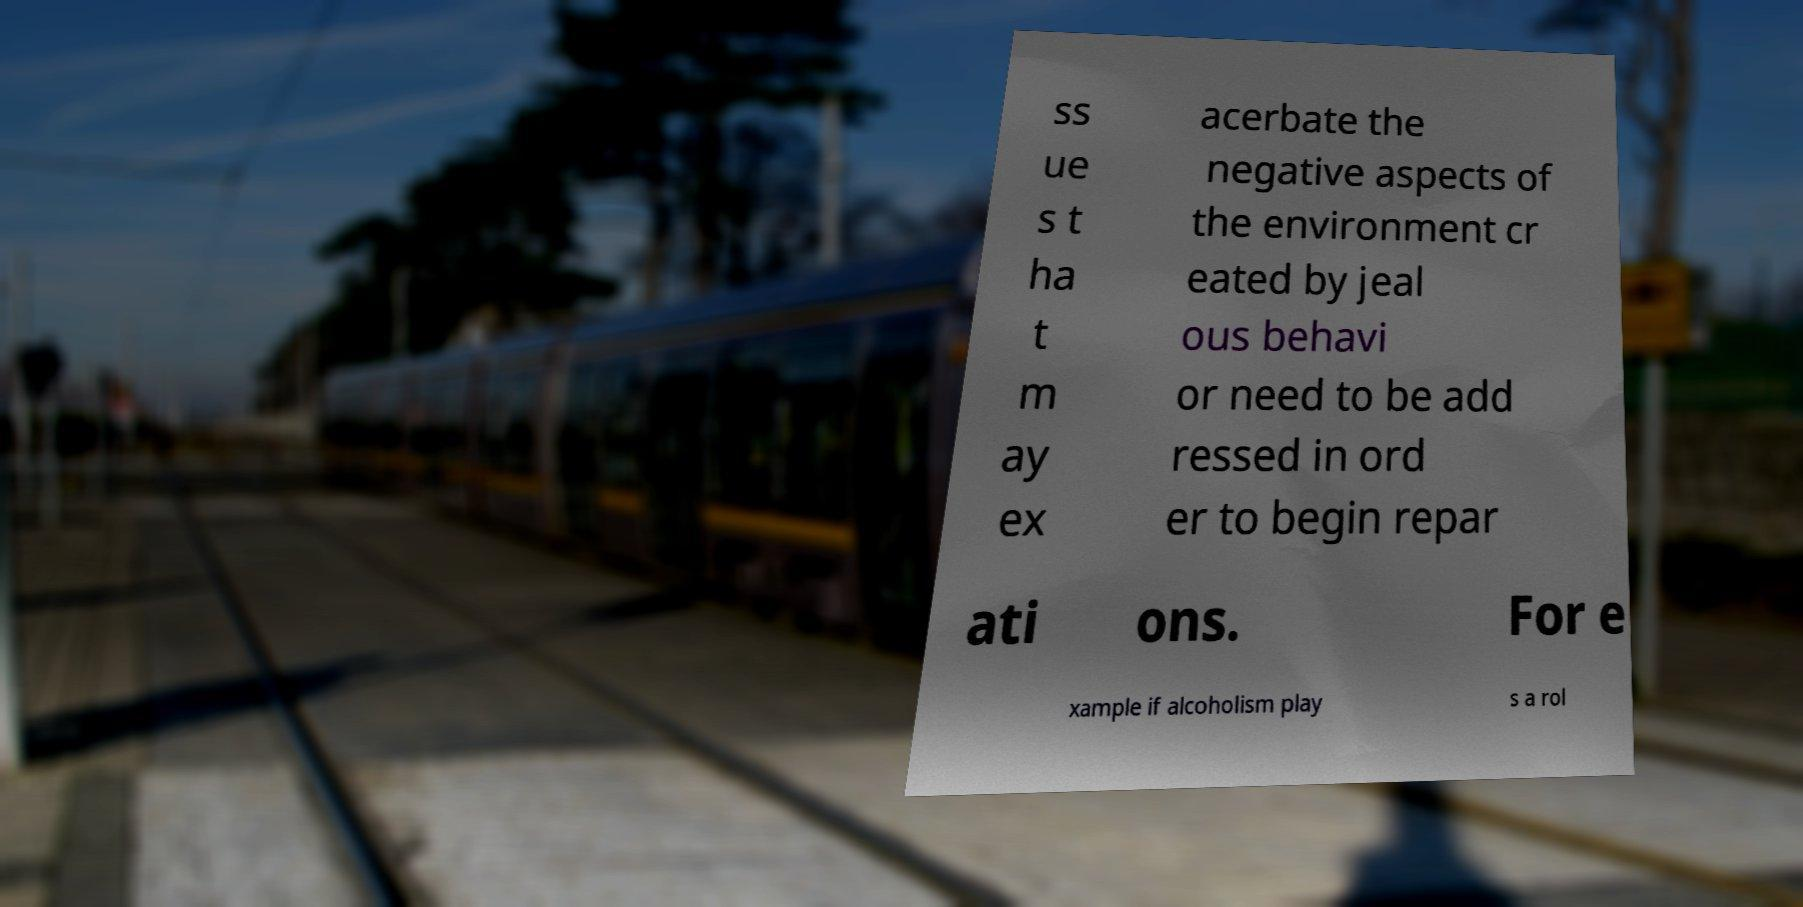Please identify and transcribe the text found in this image. ss ue s t ha t m ay ex acerbate the negative aspects of the environment cr eated by jeal ous behavi or need to be add ressed in ord er to begin repar ati ons. For e xample if alcoholism play s a rol 